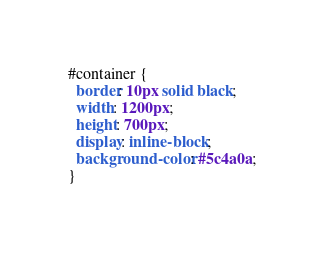Convert code to text. <code><loc_0><loc_0><loc_500><loc_500><_CSS_>#container {
  border: 10px solid black;
  width: 1200px;
  height: 700px;
  display: inline-block;
  background-color: #5c4a0a;
}
</code> 